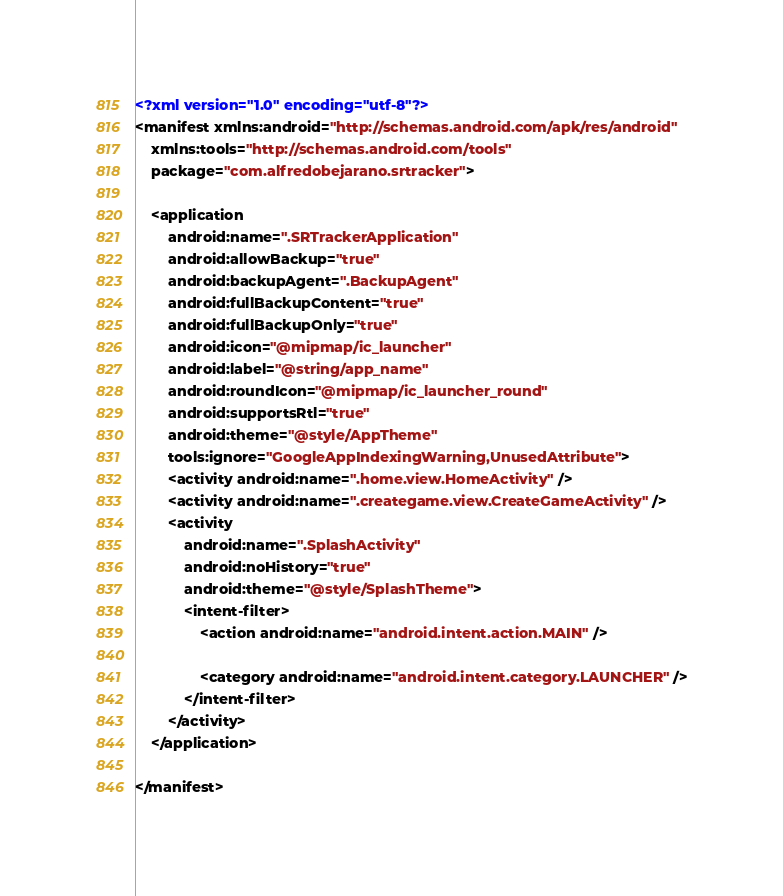<code> <loc_0><loc_0><loc_500><loc_500><_XML_><?xml version="1.0" encoding="utf-8"?>
<manifest xmlns:android="http://schemas.android.com/apk/res/android"
    xmlns:tools="http://schemas.android.com/tools"
    package="com.alfredobejarano.srtracker">

    <application
        android:name=".SRTrackerApplication"
        android:allowBackup="true"
        android:backupAgent=".BackupAgent"
        android:fullBackupContent="true"
        android:fullBackupOnly="true"
        android:icon="@mipmap/ic_launcher"
        android:label="@string/app_name"
        android:roundIcon="@mipmap/ic_launcher_round"
        android:supportsRtl="true"
        android:theme="@style/AppTheme"
        tools:ignore="GoogleAppIndexingWarning,UnusedAttribute">
        <activity android:name=".home.view.HomeActivity" />
        <activity android:name=".creategame.view.CreateGameActivity" />
        <activity
            android:name=".SplashActivity"
            android:noHistory="true"
            android:theme="@style/SplashTheme">
            <intent-filter>
                <action android:name="android.intent.action.MAIN" />

                <category android:name="android.intent.category.LAUNCHER" />
            </intent-filter>
        </activity>
    </application>

</manifest></code> 